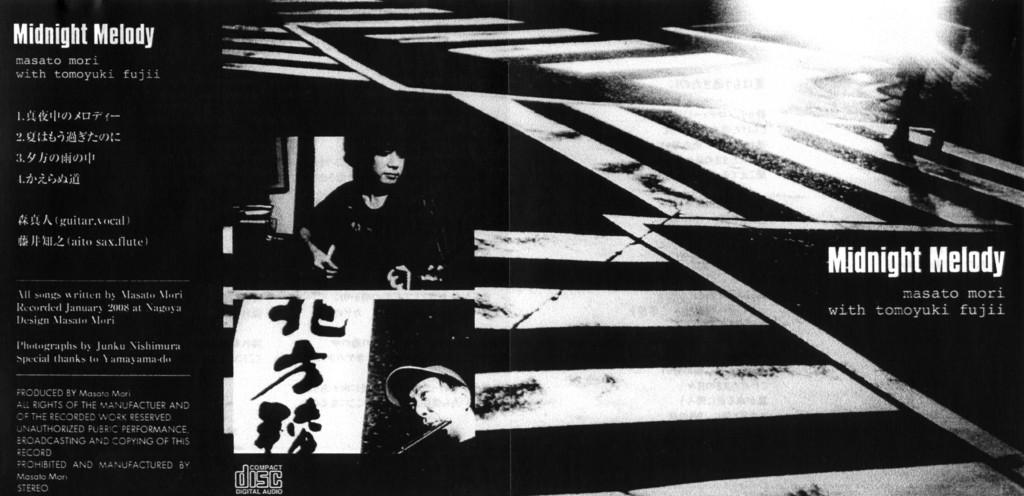<image>
Give a short and clear explanation of the subsequent image. A Japanese advertisement for a rockband called Midnight Melody. 